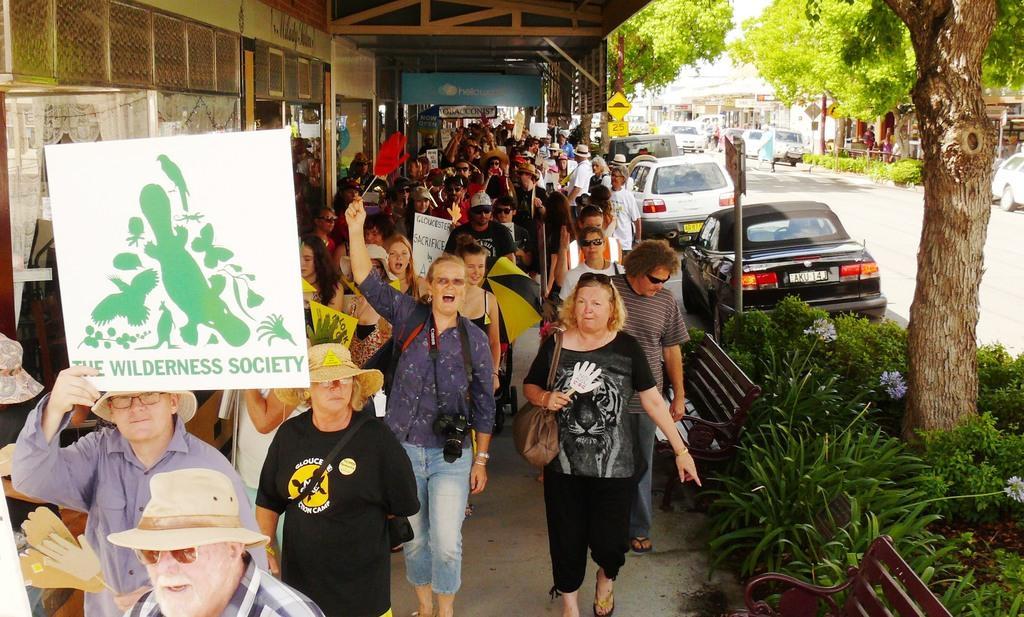Could you give a brief overview of what you see in this image? In this picture I can observe some people walking in this path. Some of them are holding boards in their hands. There are men and women in this picture. On the right side there are some cars parked on the road. I can observe some plants and trees. In the background there are buildings. 